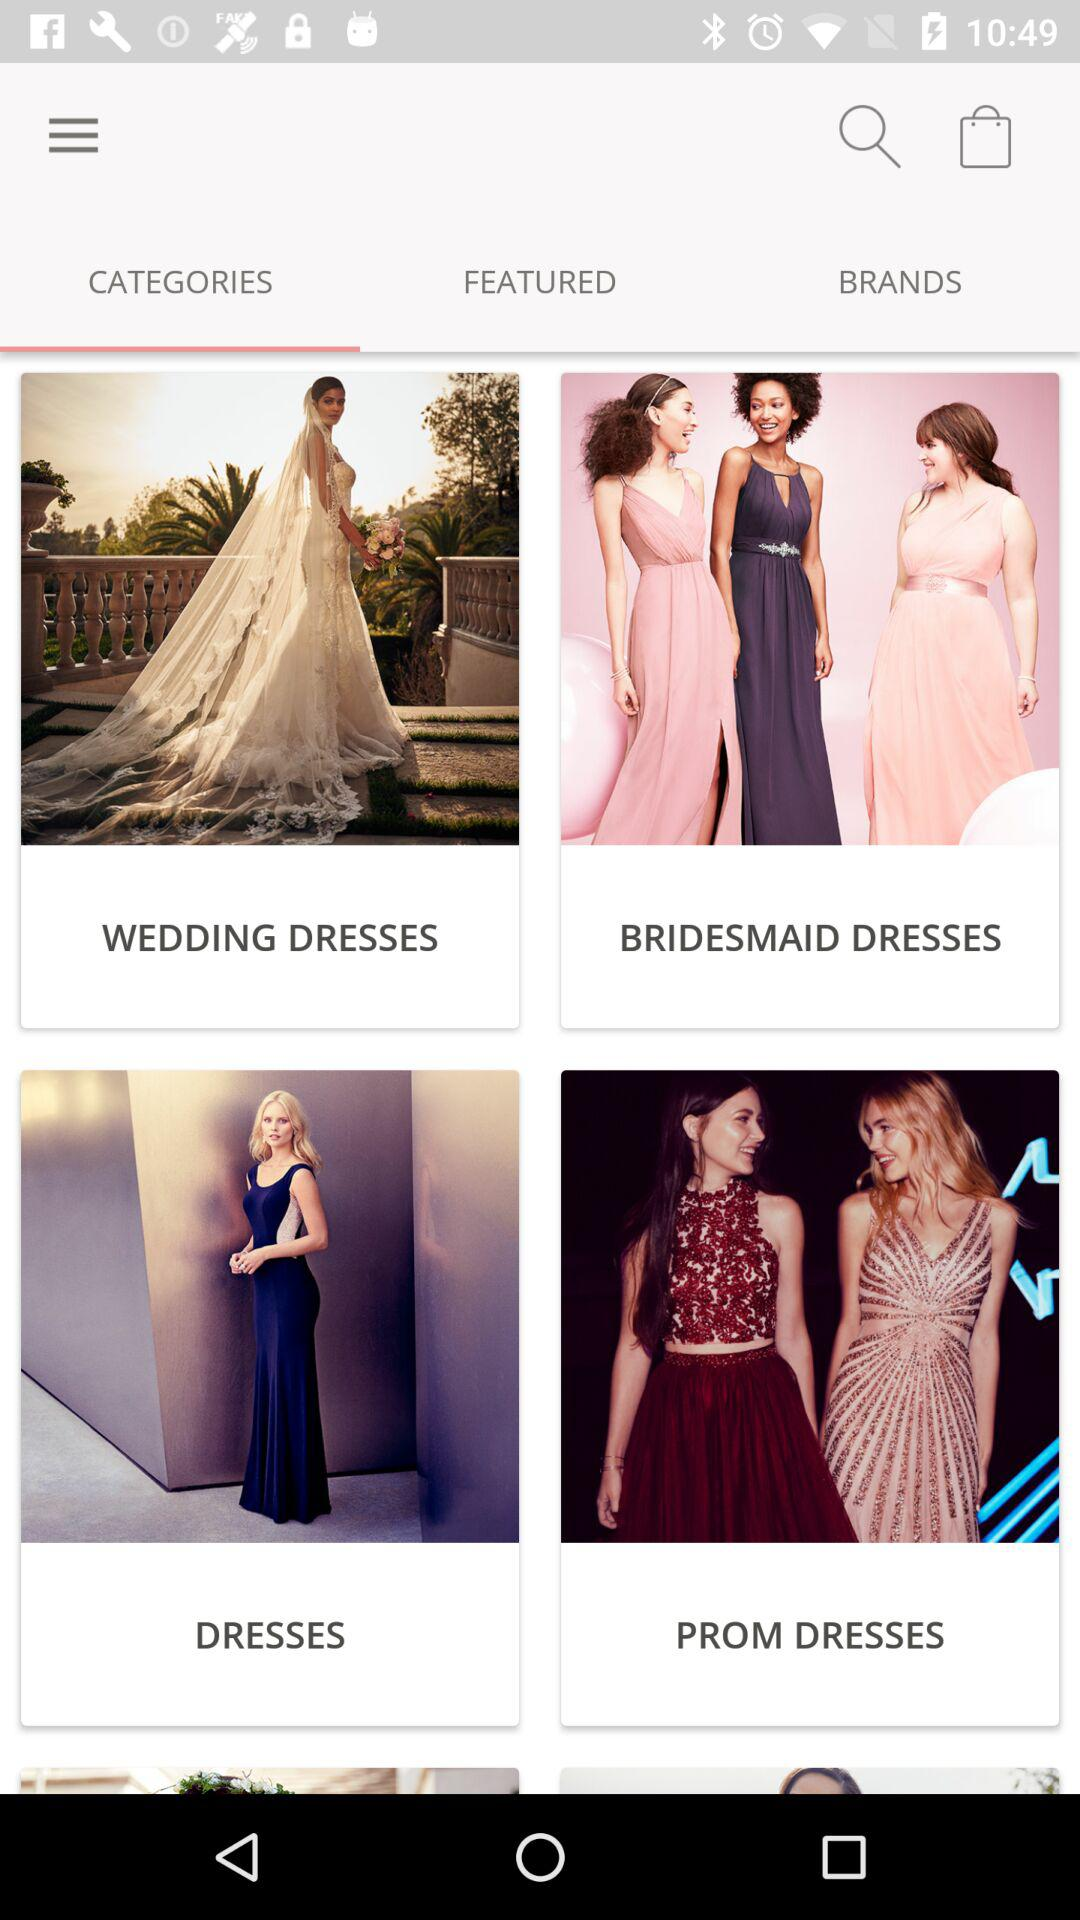Which tab is selected? The selected tab is "CATEGORIES". 